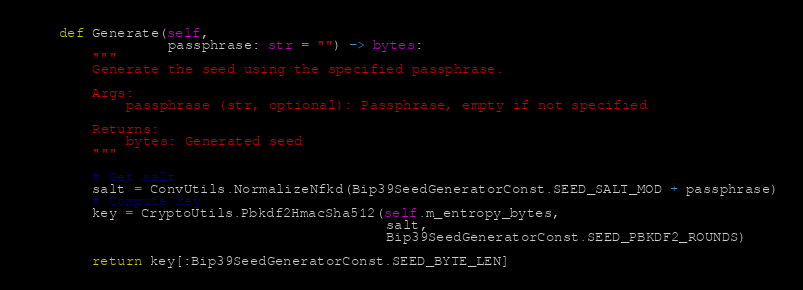Convert code to text. <code><loc_0><loc_0><loc_500><loc_500><_Python_>
    def Generate(self,
                 passphrase: str = "") -> bytes:
        """
        Generate the seed using the specified passphrase.

        Args:
            passphrase (str, optional): Passphrase, empty if not specified

        Returns:
            bytes: Generated seed
        """

        # Get salt
        salt = ConvUtils.NormalizeNfkd(Bip39SeedGeneratorConst.SEED_SALT_MOD + passphrase)
        # Compute key
        key = CryptoUtils.Pbkdf2HmacSha512(self.m_entropy_bytes,
                                           salt,
                                           Bip39SeedGeneratorConst.SEED_PBKDF2_ROUNDS)

        return key[:Bip39SeedGeneratorConst.SEED_BYTE_LEN]
</code> 